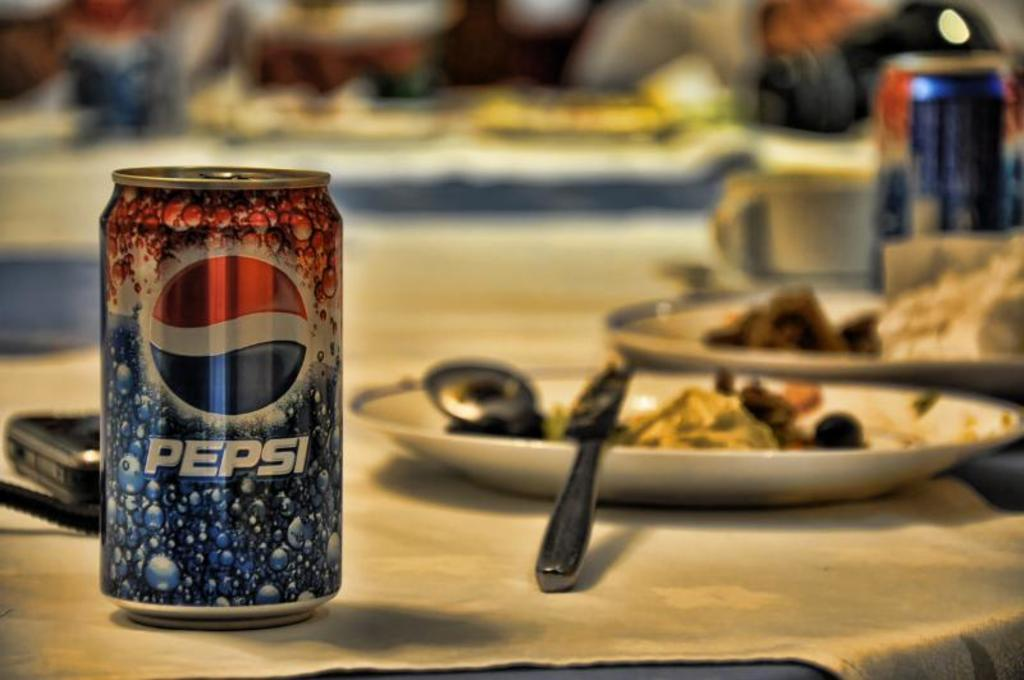What type of furniture is present in the image? There are tables in the image. What is placed on the tables? There are plates with food items and glasses on the tables. Are there any other objects on the tables? Yes, there are other objects on the tables. Can you describe the background of the image? The background of the image is blurry. What type of system is being used to control the current in the image? There is no system or reference to current control in the image; it features tables with plates, glasses, and other objects. 